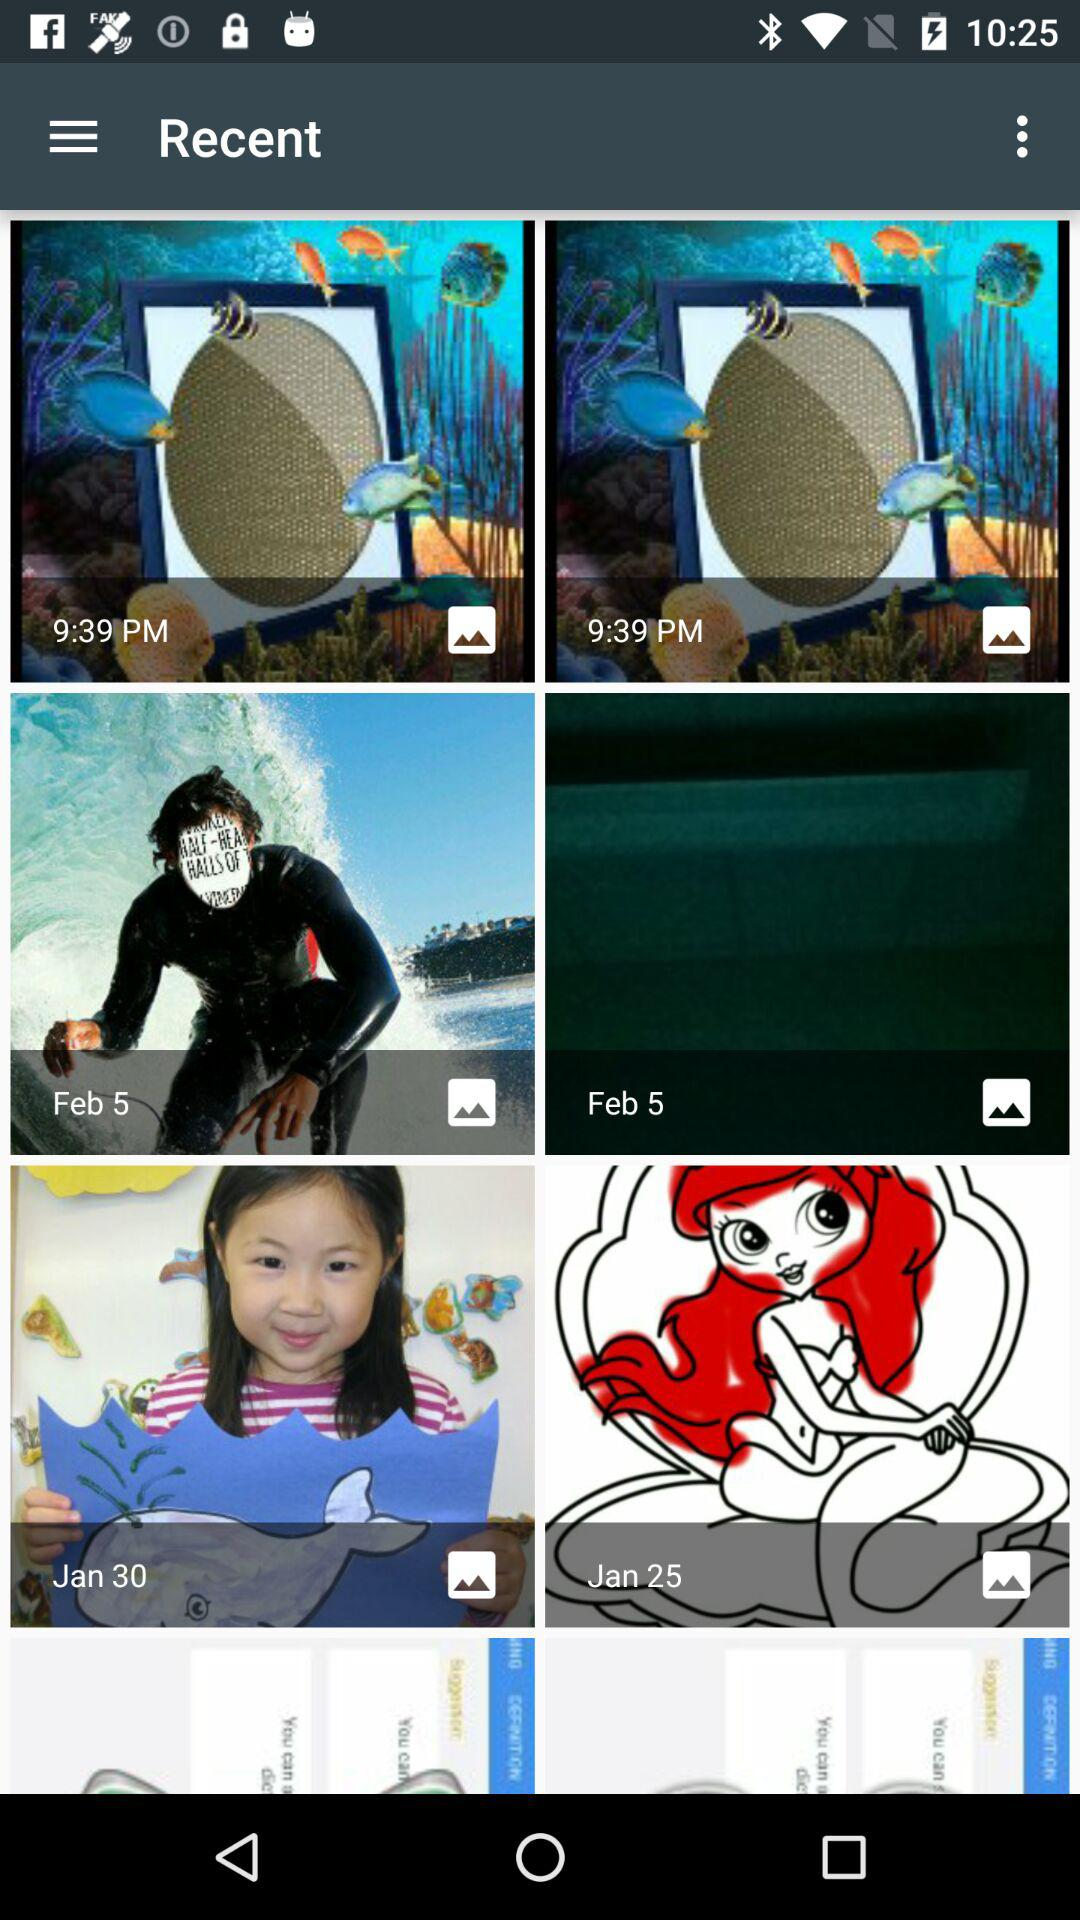What is the date of last image?
When the provided information is insufficient, respond with <no answer>. <no answer> 